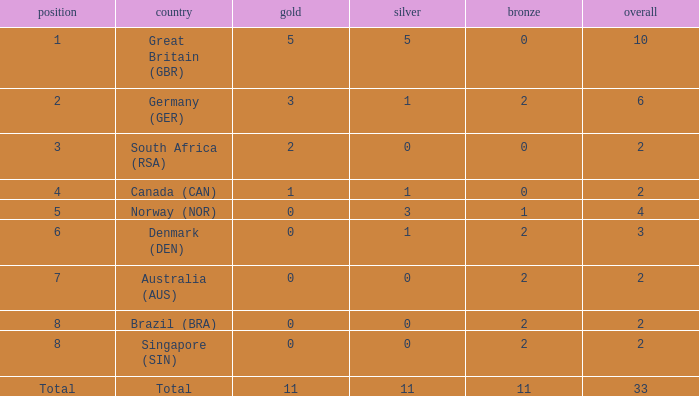What is bronze when the rank is 3 and the total is more than 2? None. 